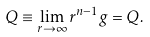Convert formula to latex. <formula><loc_0><loc_0><loc_500><loc_500>Q \equiv \lim _ { r \rightarrow \infty } r ^ { n - 1 } g = Q .</formula> 